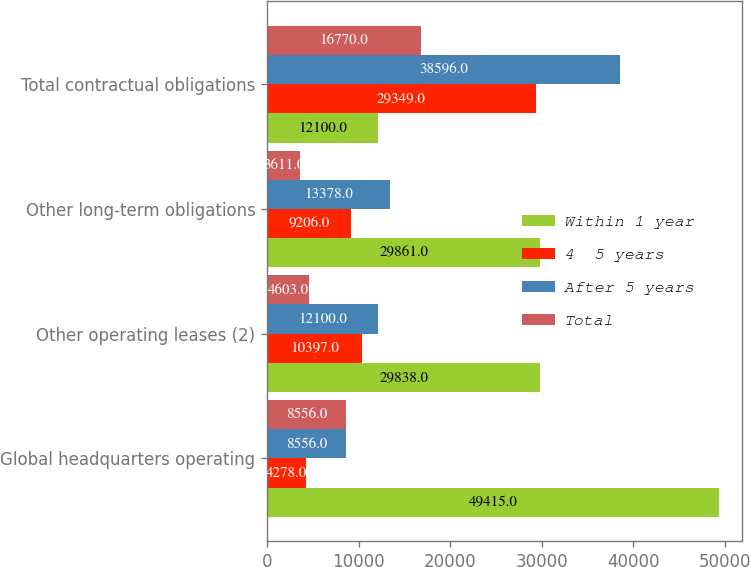<chart> <loc_0><loc_0><loc_500><loc_500><stacked_bar_chart><ecel><fcel>Global headquarters operating<fcel>Other operating leases (2)<fcel>Other long-term obligations<fcel>Total contractual obligations<nl><fcel>Within 1 year<fcel>49415<fcel>29838<fcel>29861<fcel>12100<nl><fcel>4  5 years<fcel>4278<fcel>10397<fcel>9206<fcel>29349<nl><fcel>After 5 years<fcel>8556<fcel>12100<fcel>13378<fcel>38596<nl><fcel>Total<fcel>8556<fcel>4603<fcel>3611<fcel>16770<nl></chart> 